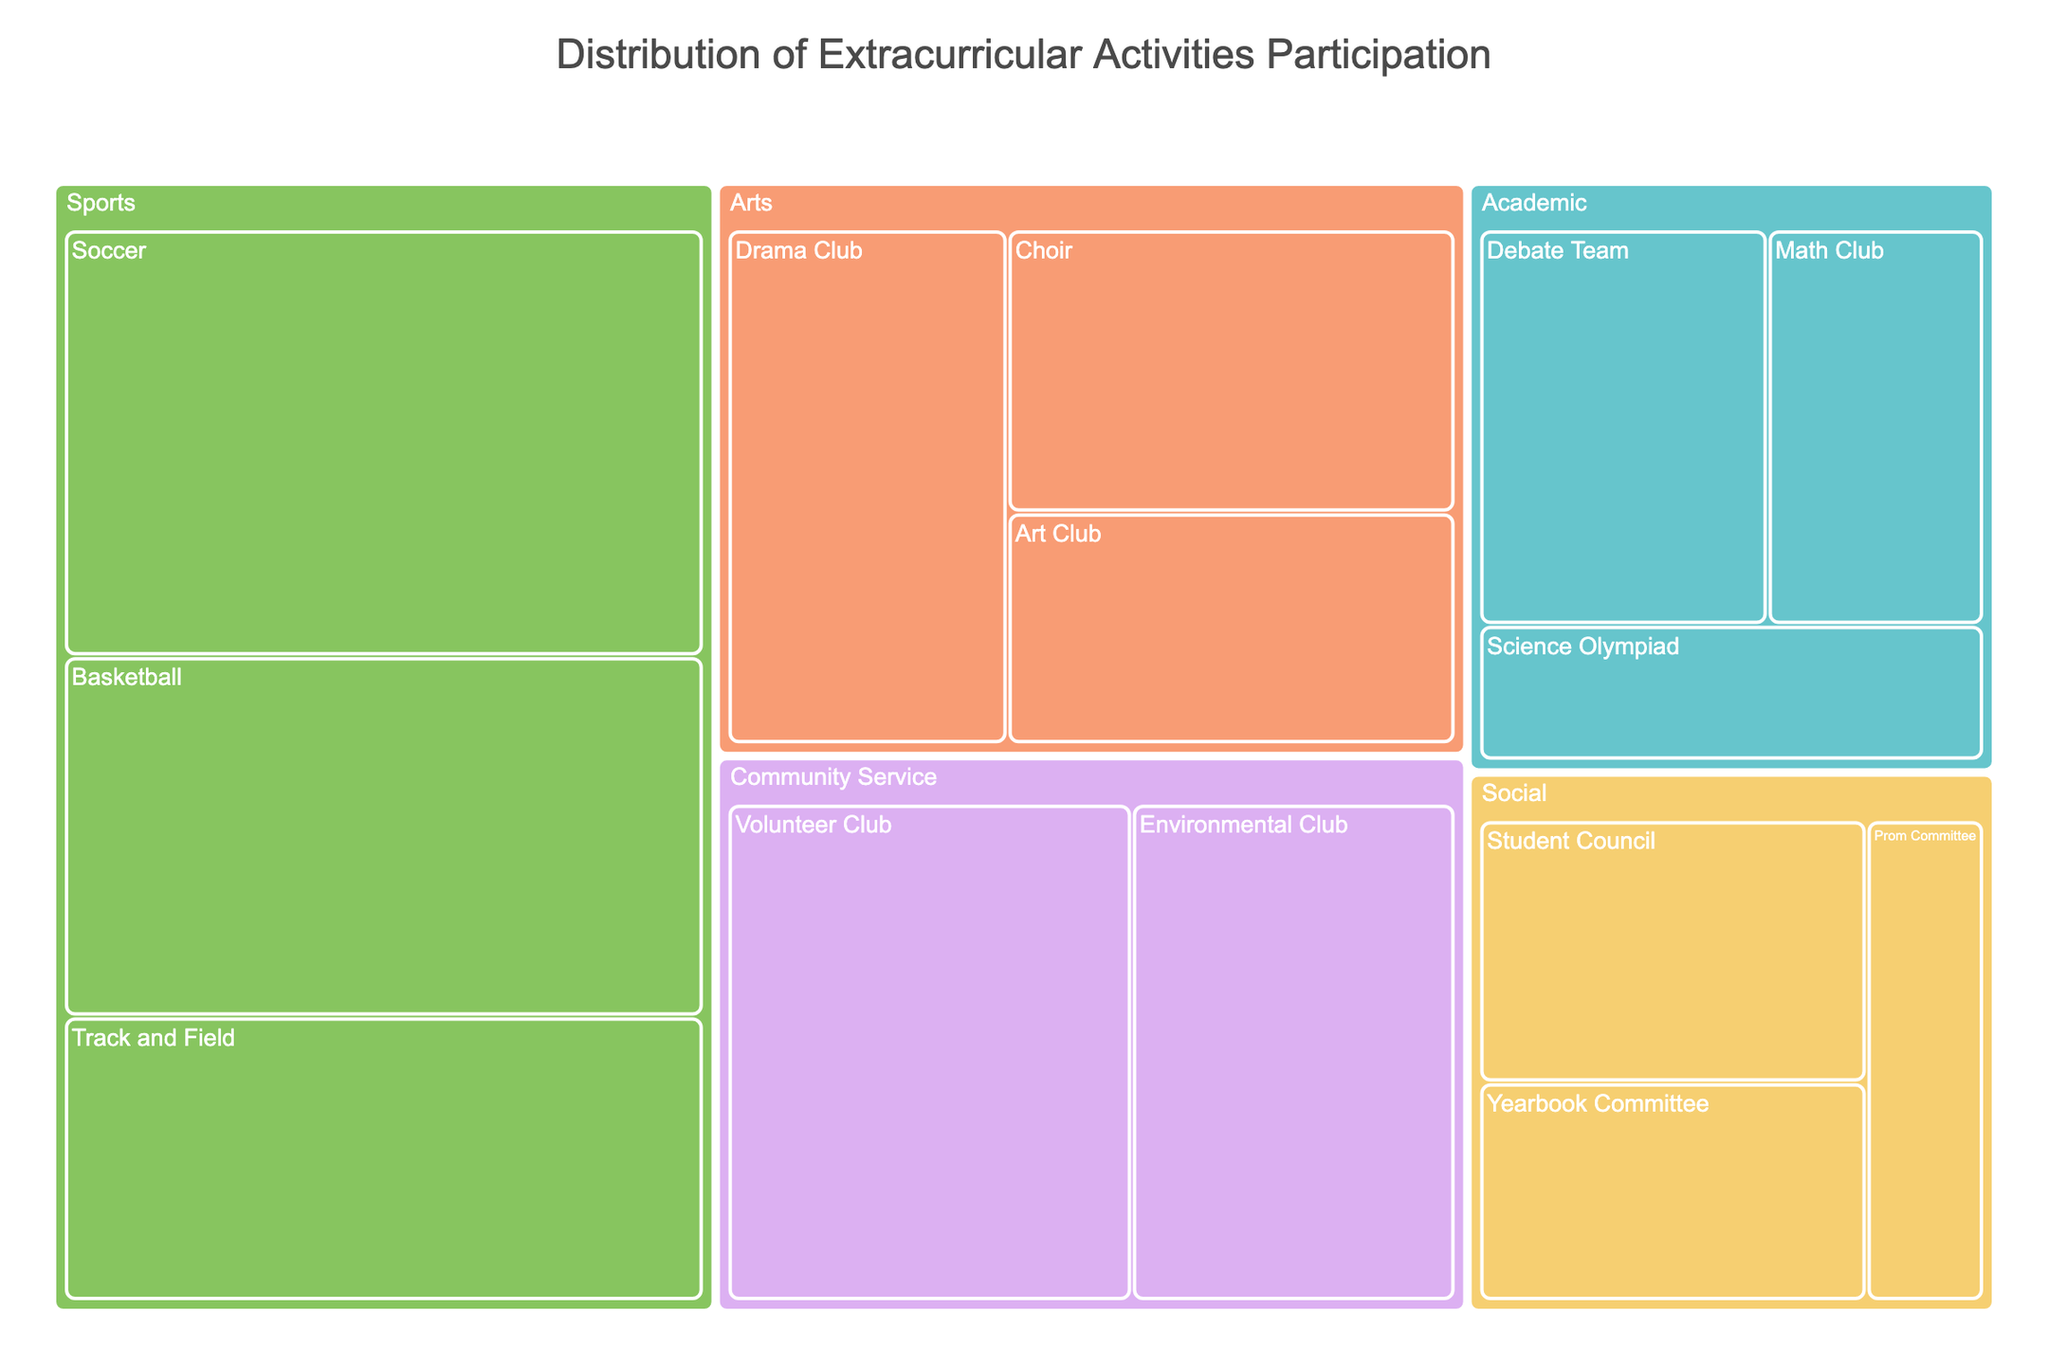What's the title of the figure? The title is typically located at the top of the figure in a larger font size. By looking at the top-center part of the figure, you can see the text indicating the title.
Answer: Distribution of Extracurricular Activities Participation Which subcategory has the highest participation? Within each category of the treemap, the subcategory with the largest area represents the highest participation. The subcategory with the largest area overall will be the one with the highest participation.
Answer: Soccer How many participants are in the Math Club? To find the participants in a specific subcategory like Math Club, you can look at the size of the subcategory within its branch and check the number indicated on the hover tooltip or visual label.
Answer: 15 What is the total number of participants in Sports activities? To determine the total number of participants in Sports activities, sum the number of participants in all subcategories under the Sports category. This includes Soccer (45), Basketball (38), and Track and Field (30).
Answer: 113 Which category has the least participation overall? The category with the smallest total area indicates the least participation. By comparing the areas of all categories visually, you can identify the smallest one.
Answer: Academic Compare the participation between Drama Club and Choir. Which has more participants? Locate the Drama Club and Choir sections within the Arts category and compare their sizes. The number of participants is also displayed in the tooltip or label.
Answer: Drama Club has more participants How many categories and subcategories are shown in the treemap? Count the distinct categories and their respective subcategories. Each category is displayed as a major branch, and subcategories are nested within them.
Answer: 5 categories, 14 subcategories Which subcategory in Community Service has more participants? Look within the Community Service category's branch in the treemap and compare the two subcategories, Volunteer Club and Environmental Club, to see which has a larger area.
Answer: Volunteer Club What is the average number of participants in the Academic category? Add the number of participants in all subcategories under Academic (Debate Team, Math Club, Science Olympiad) and divide by the number of subcategories (3). This is calculated as (20 + 15 + 12) / 3.
Answer: 15.67 Which subcategory has the smallest participation, and how many participants does it have? Identify the subcategory with the smallest area in the entire treemap. The number of participants can be seen from the visual label or tooltip.
Answer: Prom Committee, 10 